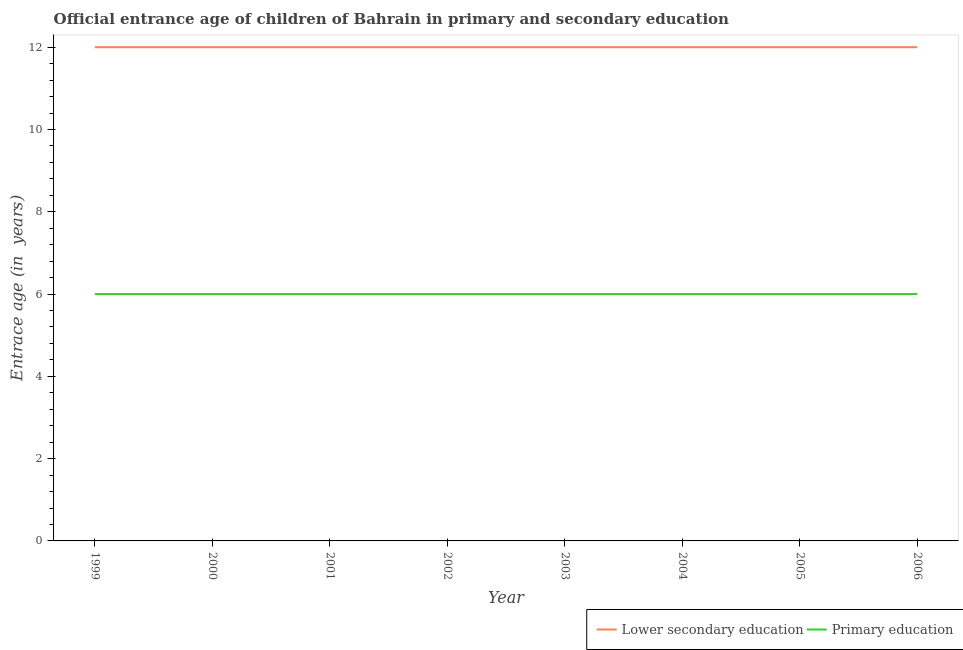How many different coloured lines are there?
Your answer should be compact. 2. Is the number of lines equal to the number of legend labels?
Make the answer very short. Yes. What is the entrance age of children in lower secondary education in 2006?
Your answer should be compact. 12. Across all years, what is the maximum entrance age of children in lower secondary education?
Provide a short and direct response. 12. Across all years, what is the minimum entrance age of children in lower secondary education?
Give a very brief answer. 12. In which year was the entrance age of chiildren in primary education minimum?
Provide a short and direct response. 1999. What is the total entrance age of children in lower secondary education in the graph?
Offer a terse response. 96. What is the difference between the entrance age of children in lower secondary education in 2000 and that in 2001?
Provide a succinct answer. 0. In the year 2005, what is the difference between the entrance age of chiildren in primary education and entrance age of children in lower secondary education?
Your response must be concise. -6. In how many years, is the entrance age of chiildren in primary education greater than 7.6 years?
Your response must be concise. 0. What is the ratio of the entrance age of children in lower secondary education in 2003 to that in 2004?
Offer a terse response. 1. Is the entrance age of children in lower secondary education in 2002 less than that in 2005?
Your answer should be very brief. No. What is the difference between the highest and the lowest entrance age of children in lower secondary education?
Your response must be concise. 0. In how many years, is the entrance age of chiildren in primary education greater than the average entrance age of chiildren in primary education taken over all years?
Ensure brevity in your answer.  0. Is the sum of the entrance age of chiildren in primary education in 1999 and 2003 greater than the maximum entrance age of children in lower secondary education across all years?
Provide a succinct answer. No. Does the entrance age of children in lower secondary education monotonically increase over the years?
Provide a succinct answer. No. Is the entrance age of children in lower secondary education strictly less than the entrance age of chiildren in primary education over the years?
Ensure brevity in your answer.  No. How many lines are there?
Offer a terse response. 2. Does the graph contain grids?
Keep it short and to the point. No. Where does the legend appear in the graph?
Offer a very short reply. Bottom right. What is the title of the graph?
Make the answer very short. Official entrance age of children of Bahrain in primary and secondary education. What is the label or title of the X-axis?
Provide a short and direct response. Year. What is the label or title of the Y-axis?
Offer a terse response. Entrace age (in  years). What is the Entrace age (in  years) of Lower secondary education in 1999?
Your answer should be compact. 12. What is the Entrace age (in  years) of Primary education in 1999?
Offer a very short reply. 6. What is the Entrace age (in  years) in Lower secondary education in 2000?
Your answer should be very brief. 12. What is the Entrace age (in  years) in Primary education in 2001?
Your answer should be compact. 6. What is the Entrace age (in  years) of Primary education in 2003?
Your response must be concise. 6. What is the Entrace age (in  years) of Lower secondary education in 2005?
Make the answer very short. 12. What is the Entrace age (in  years) of Lower secondary education in 2006?
Make the answer very short. 12. What is the Entrace age (in  years) of Primary education in 2006?
Offer a very short reply. 6. Across all years, what is the maximum Entrace age (in  years) of Lower secondary education?
Your answer should be compact. 12. Across all years, what is the minimum Entrace age (in  years) of Lower secondary education?
Keep it short and to the point. 12. What is the total Entrace age (in  years) of Lower secondary education in the graph?
Your answer should be compact. 96. What is the total Entrace age (in  years) of Primary education in the graph?
Offer a terse response. 48. What is the difference between the Entrace age (in  years) in Primary education in 1999 and that in 2000?
Your answer should be compact. 0. What is the difference between the Entrace age (in  years) in Lower secondary education in 1999 and that in 2002?
Your answer should be very brief. 0. What is the difference between the Entrace age (in  years) in Primary education in 1999 and that in 2002?
Offer a very short reply. 0. What is the difference between the Entrace age (in  years) in Primary education in 1999 and that in 2003?
Your answer should be very brief. 0. What is the difference between the Entrace age (in  years) of Lower secondary education in 1999 and that in 2004?
Ensure brevity in your answer.  0. What is the difference between the Entrace age (in  years) of Lower secondary education in 1999 and that in 2005?
Make the answer very short. 0. What is the difference between the Entrace age (in  years) in Lower secondary education in 1999 and that in 2006?
Keep it short and to the point. 0. What is the difference between the Entrace age (in  years) in Lower secondary education in 2000 and that in 2002?
Your answer should be compact. 0. What is the difference between the Entrace age (in  years) of Primary education in 2000 and that in 2002?
Keep it short and to the point. 0. What is the difference between the Entrace age (in  years) in Primary education in 2000 and that in 2003?
Keep it short and to the point. 0. What is the difference between the Entrace age (in  years) in Lower secondary education in 2000 and that in 2004?
Your response must be concise. 0. What is the difference between the Entrace age (in  years) in Primary education in 2000 and that in 2004?
Your response must be concise. 0. What is the difference between the Entrace age (in  years) of Lower secondary education in 2001 and that in 2002?
Your answer should be very brief. 0. What is the difference between the Entrace age (in  years) in Primary education in 2001 and that in 2002?
Keep it short and to the point. 0. What is the difference between the Entrace age (in  years) of Lower secondary education in 2001 and that in 2003?
Provide a succinct answer. 0. What is the difference between the Entrace age (in  years) in Lower secondary education in 2001 and that in 2004?
Provide a succinct answer. 0. What is the difference between the Entrace age (in  years) in Primary education in 2001 and that in 2004?
Your response must be concise. 0. What is the difference between the Entrace age (in  years) of Primary education in 2001 and that in 2005?
Provide a succinct answer. 0. What is the difference between the Entrace age (in  years) of Lower secondary education in 2001 and that in 2006?
Your response must be concise. 0. What is the difference between the Entrace age (in  years) of Primary education in 2001 and that in 2006?
Provide a short and direct response. 0. What is the difference between the Entrace age (in  years) of Primary education in 2002 and that in 2003?
Make the answer very short. 0. What is the difference between the Entrace age (in  years) in Lower secondary education in 2002 and that in 2004?
Offer a terse response. 0. What is the difference between the Entrace age (in  years) of Primary education in 2002 and that in 2006?
Your response must be concise. 0. What is the difference between the Entrace age (in  years) of Primary education in 2003 and that in 2004?
Provide a succinct answer. 0. What is the difference between the Entrace age (in  years) of Primary education in 2003 and that in 2006?
Provide a succinct answer. 0. What is the difference between the Entrace age (in  years) in Primary education in 2004 and that in 2005?
Your response must be concise. 0. What is the difference between the Entrace age (in  years) of Primary education in 2005 and that in 2006?
Ensure brevity in your answer.  0. What is the difference between the Entrace age (in  years) of Lower secondary education in 1999 and the Entrace age (in  years) of Primary education in 2000?
Your answer should be compact. 6. What is the difference between the Entrace age (in  years) of Lower secondary education in 1999 and the Entrace age (in  years) of Primary education in 2001?
Offer a very short reply. 6. What is the difference between the Entrace age (in  years) of Lower secondary education in 1999 and the Entrace age (in  years) of Primary education in 2002?
Ensure brevity in your answer.  6. What is the difference between the Entrace age (in  years) of Lower secondary education in 1999 and the Entrace age (in  years) of Primary education in 2003?
Make the answer very short. 6. What is the difference between the Entrace age (in  years) of Lower secondary education in 1999 and the Entrace age (in  years) of Primary education in 2005?
Your answer should be compact. 6. What is the difference between the Entrace age (in  years) of Lower secondary education in 2000 and the Entrace age (in  years) of Primary education in 2001?
Offer a terse response. 6. What is the difference between the Entrace age (in  years) in Lower secondary education in 2000 and the Entrace age (in  years) in Primary education in 2002?
Provide a short and direct response. 6. What is the difference between the Entrace age (in  years) of Lower secondary education in 2000 and the Entrace age (in  years) of Primary education in 2003?
Provide a succinct answer. 6. What is the difference between the Entrace age (in  years) in Lower secondary education in 2000 and the Entrace age (in  years) in Primary education in 2006?
Offer a very short reply. 6. What is the difference between the Entrace age (in  years) in Lower secondary education in 2001 and the Entrace age (in  years) in Primary education in 2002?
Offer a very short reply. 6. What is the difference between the Entrace age (in  years) in Lower secondary education in 2001 and the Entrace age (in  years) in Primary education in 2005?
Provide a succinct answer. 6. What is the difference between the Entrace age (in  years) in Lower secondary education in 2002 and the Entrace age (in  years) in Primary education in 2003?
Your response must be concise. 6. What is the difference between the Entrace age (in  years) of Lower secondary education in 2002 and the Entrace age (in  years) of Primary education in 2004?
Keep it short and to the point. 6. What is the difference between the Entrace age (in  years) in Lower secondary education in 2002 and the Entrace age (in  years) in Primary education in 2005?
Keep it short and to the point. 6. What is the difference between the Entrace age (in  years) of Lower secondary education in 2003 and the Entrace age (in  years) of Primary education in 2004?
Make the answer very short. 6. What is the difference between the Entrace age (in  years) in Lower secondary education in 2004 and the Entrace age (in  years) in Primary education in 2006?
Offer a terse response. 6. What is the difference between the Entrace age (in  years) in Lower secondary education in 2005 and the Entrace age (in  years) in Primary education in 2006?
Your answer should be compact. 6. What is the average Entrace age (in  years) of Primary education per year?
Provide a short and direct response. 6. In the year 1999, what is the difference between the Entrace age (in  years) in Lower secondary education and Entrace age (in  years) in Primary education?
Provide a short and direct response. 6. In the year 2002, what is the difference between the Entrace age (in  years) of Lower secondary education and Entrace age (in  years) of Primary education?
Offer a terse response. 6. In the year 2003, what is the difference between the Entrace age (in  years) in Lower secondary education and Entrace age (in  years) in Primary education?
Make the answer very short. 6. In the year 2004, what is the difference between the Entrace age (in  years) of Lower secondary education and Entrace age (in  years) of Primary education?
Your response must be concise. 6. In the year 2005, what is the difference between the Entrace age (in  years) of Lower secondary education and Entrace age (in  years) of Primary education?
Your response must be concise. 6. What is the ratio of the Entrace age (in  years) of Primary education in 1999 to that in 2001?
Offer a very short reply. 1. What is the ratio of the Entrace age (in  years) of Lower secondary education in 1999 to that in 2002?
Offer a very short reply. 1. What is the ratio of the Entrace age (in  years) in Lower secondary education in 1999 to that in 2003?
Give a very brief answer. 1. What is the ratio of the Entrace age (in  years) in Primary education in 1999 to that in 2003?
Offer a very short reply. 1. What is the ratio of the Entrace age (in  years) of Lower secondary education in 1999 to that in 2004?
Offer a terse response. 1. What is the ratio of the Entrace age (in  years) in Primary education in 1999 to that in 2004?
Your answer should be compact. 1. What is the ratio of the Entrace age (in  years) in Primary education in 1999 to that in 2005?
Offer a terse response. 1. What is the ratio of the Entrace age (in  years) in Primary education in 1999 to that in 2006?
Your answer should be very brief. 1. What is the ratio of the Entrace age (in  years) of Lower secondary education in 2000 to that in 2001?
Your response must be concise. 1. What is the ratio of the Entrace age (in  years) in Primary education in 2000 to that in 2001?
Make the answer very short. 1. What is the ratio of the Entrace age (in  years) in Lower secondary education in 2000 to that in 2002?
Provide a short and direct response. 1. What is the ratio of the Entrace age (in  years) in Lower secondary education in 2000 to that in 2003?
Offer a terse response. 1. What is the ratio of the Entrace age (in  years) of Lower secondary education in 2000 to that in 2005?
Make the answer very short. 1. What is the ratio of the Entrace age (in  years) of Primary education in 2000 to that in 2005?
Give a very brief answer. 1. What is the ratio of the Entrace age (in  years) in Primary education in 2000 to that in 2006?
Make the answer very short. 1. What is the ratio of the Entrace age (in  years) of Primary education in 2001 to that in 2003?
Make the answer very short. 1. What is the ratio of the Entrace age (in  years) of Lower secondary education in 2001 to that in 2004?
Make the answer very short. 1. What is the ratio of the Entrace age (in  years) in Primary education in 2001 to that in 2004?
Offer a very short reply. 1. What is the ratio of the Entrace age (in  years) in Lower secondary education in 2001 to that in 2005?
Your answer should be very brief. 1. What is the ratio of the Entrace age (in  years) of Primary education in 2001 to that in 2005?
Ensure brevity in your answer.  1. What is the ratio of the Entrace age (in  years) of Lower secondary education in 2002 to that in 2003?
Ensure brevity in your answer.  1. What is the ratio of the Entrace age (in  years) of Lower secondary education in 2002 to that in 2004?
Your answer should be very brief. 1. What is the ratio of the Entrace age (in  years) in Primary education in 2002 to that in 2004?
Your response must be concise. 1. What is the ratio of the Entrace age (in  years) of Lower secondary education in 2002 to that in 2005?
Your answer should be very brief. 1. What is the ratio of the Entrace age (in  years) in Primary education in 2002 to that in 2005?
Give a very brief answer. 1. What is the ratio of the Entrace age (in  years) of Lower secondary education in 2002 to that in 2006?
Provide a succinct answer. 1. What is the ratio of the Entrace age (in  years) of Primary education in 2002 to that in 2006?
Provide a short and direct response. 1. What is the ratio of the Entrace age (in  years) of Primary education in 2003 to that in 2004?
Make the answer very short. 1. What is the ratio of the Entrace age (in  years) of Lower secondary education in 2003 to that in 2005?
Provide a short and direct response. 1. What is the ratio of the Entrace age (in  years) in Lower secondary education in 2003 to that in 2006?
Offer a very short reply. 1. What is the ratio of the Entrace age (in  years) in Primary education in 2003 to that in 2006?
Provide a succinct answer. 1. What is the ratio of the Entrace age (in  years) of Primary education in 2004 to that in 2005?
Make the answer very short. 1. What is the ratio of the Entrace age (in  years) of Lower secondary education in 2004 to that in 2006?
Keep it short and to the point. 1. What is the ratio of the Entrace age (in  years) in Primary education in 2004 to that in 2006?
Give a very brief answer. 1. What is the ratio of the Entrace age (in  years) of Lower secondary education in 2005 to that in 2006?
Give a very brief answer. 1. What is the difference between the highest and the second highest Entrace age (in  years) in Primary education?
Your answer should be compact. 0. What is the difference between the highest and the lowest Entrace age (in  years) of Lower secondary education?
Provide a short and direct response. 0. What is the difference between the highest and the lowest Entrace age (in  years) in Primary education?
Keep it short and to the point. 0. 